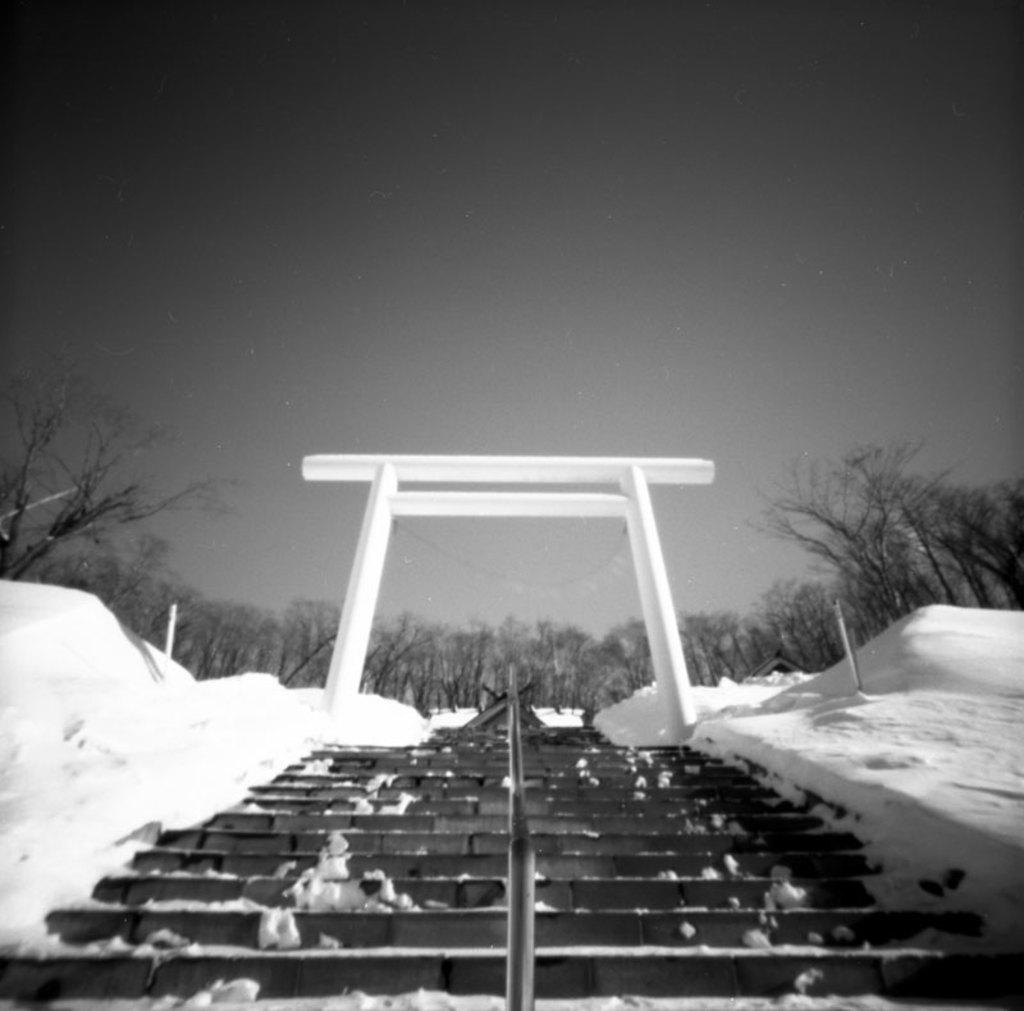What is the main structure in the center of the image? There is an arch in the center of the image. What can be seen at the bottom of the image? There are stairs at the bottom of the image. What type of natural environment is visible in the background of the image? There are trees and snow in the background of the image. What else can be seen in the background of the image? The sky is visible in the background of the image. What type of hill can be seen in the image? There is no hill present in the image. What kind of carriage is used to transport people through the arch in the image? There is no carriage present in the image; it only features an arch, stairs, trees, snow, and the sky. 